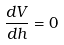Convert formula to latex. <formula><loc_0><loc_0><loc_500><loc_500>\frac { d V } { d h } = 0</formula> 